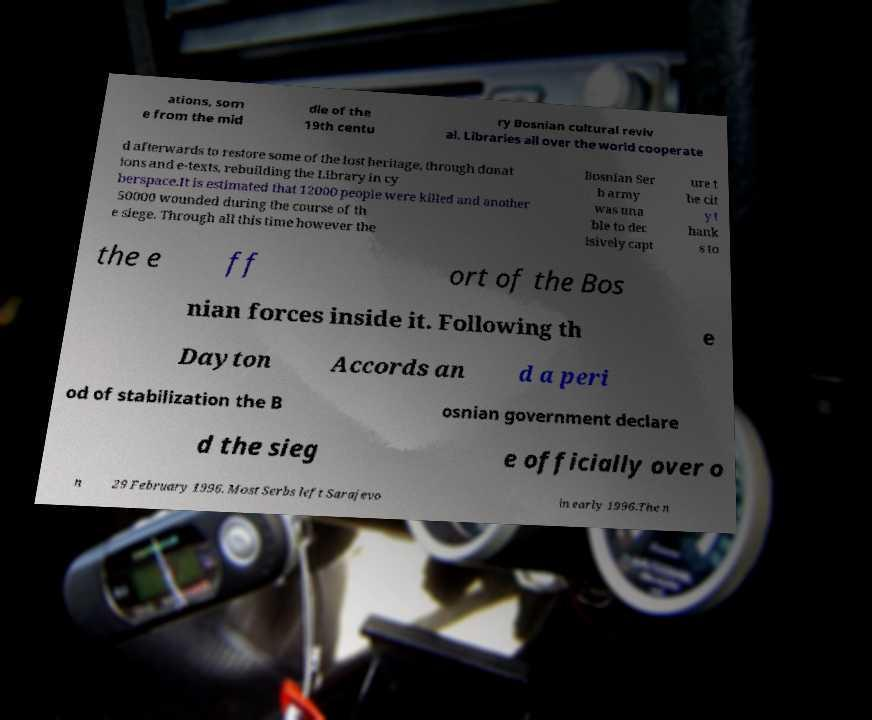Please identify and transcribe the text found in this image. ations, som e from the mid dle of the 19th centu ry Bosnian cultural reviv al. Libraries all over the world cooperate d afterwards to restore some of the lost heritage, through donat ions and e-texts, rebuilding the Library in cy berspace.It is estimated that 12000 people were killed and another 50000 wounded during the course of th e siege. Through all this time however the Bosnian Ser b army was una ble to dec isively capt ure t he cit y t hank s to the e ff ort of the Bos nian forces inside it. Following th e Dayton Accords an d a peri od of stabilization the B osnian government declare d the sieg e officially over o n 29 February 1996. Most Serbs left Sarajevo in early 1996.The n 